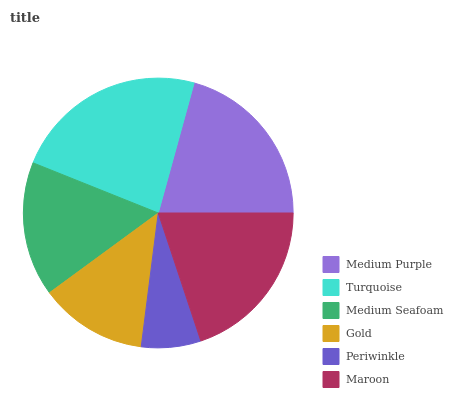Is Periwinkle the minimum?
Answer yes or no. Yes. Is Turquoise the maximum?
Answer yes or no. Yes. Is Medium Seafoam the minimum?
Answer yes or no. No. Is Medium Seafoam the maximum?
Answer yes or no. No. Is Turquoise greater than Medium Seafoam?
Answer yes or no. Yes. Is Medium Seafoam less than Turquoise?
Answer yes or no. Yes. Is Medium Seafoam greater than Turquoise?
Answer yes or no. No. Is Turquoise less than Medium Seafoam?
Answer yes or no. No. Is Maroon the high median?
Answer yes or no. Yes. Is Medium Seafoam the low median?
Answer yes or no. Yes. Is Periwinkle the high median?
Answer yes or no. No. Is Periwinkle the low median?
Answer yes or no. No. 